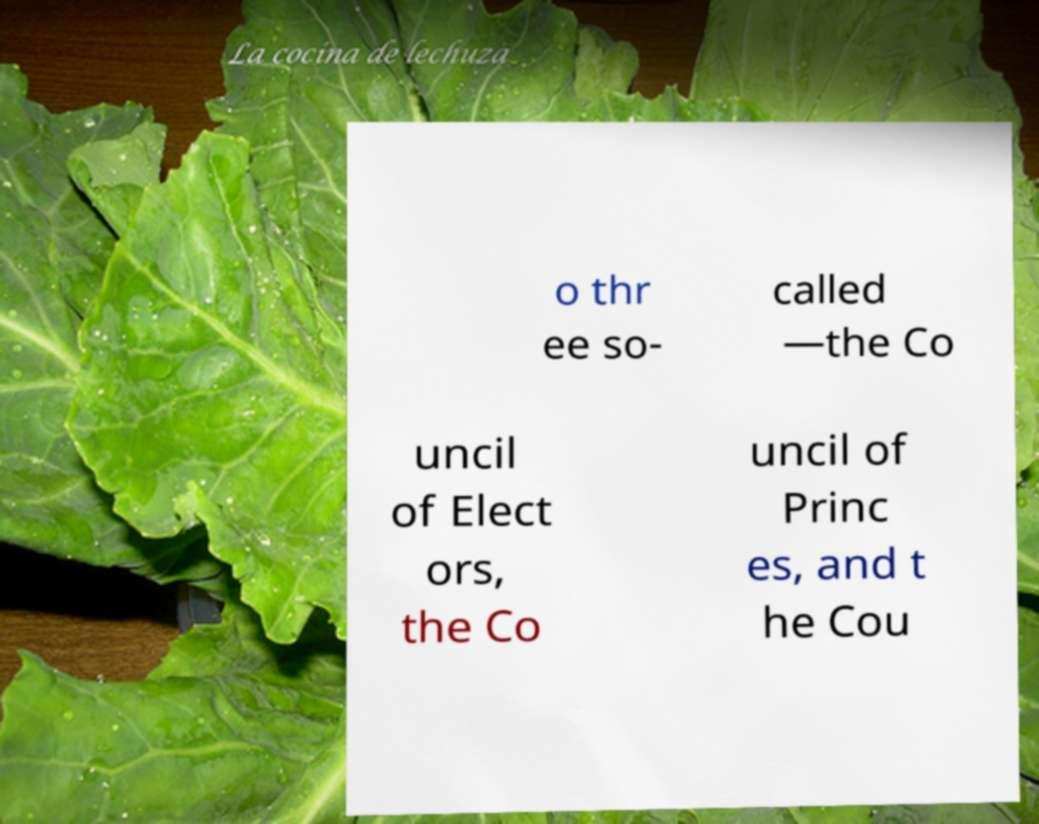What messages or text are displayed in this image? I need them in a readable, typed format. o thr ee so- called —the Co uncil of Elect ors, the Co uncil of Princ es, and t he Cou 